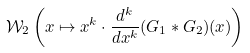Convert formula to latex. <formula><loc_0><loc_0><loc_500><loc_500>\mathcal { W } _ { 2 } \left ( x \mapsto x ^ { k } \cdot \frac { d ^ { k } } { d x ^ { k } } ( G _ { 1 } \ast G _ { 2 } ) ( x ) \right )</formula> 